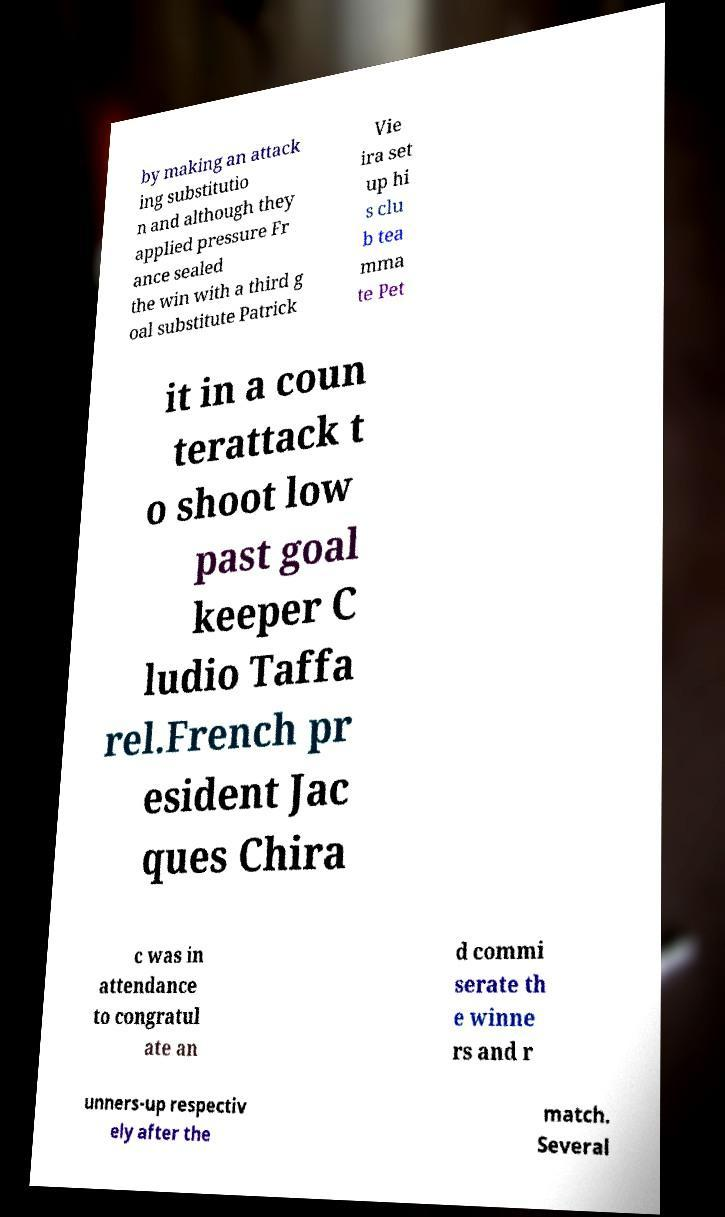For documentation purposes, I need the text within this image transcribed. Could you provide that? by making an attack ing substitutio n and although they applied pressure Fr ance sealed the win with a third g oal substitute Patrick Vie ira set up hi s clu b tea mma te Pet it in a coun terattack t o shoot low past goal keeper C ludio Taffa rel.French pr esident Jac ques Chira c was in attendance to congratul ate an d commi serate th e winne rs and r unners-up respectiv ely after the match. Several 